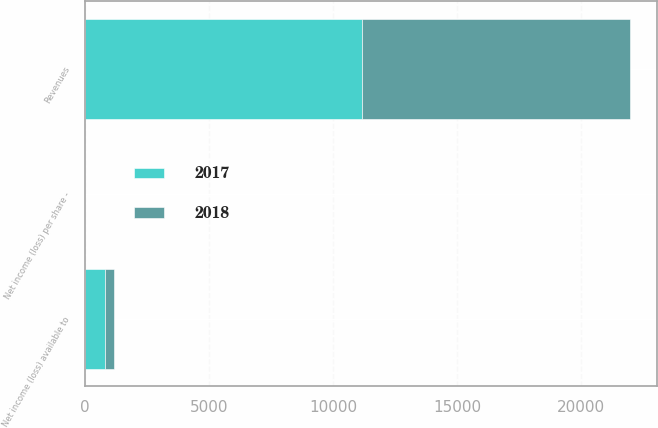Convert chart. <chart><loc_0><loc_0><loc_500><loc_500><stacked_bar_chart><ecel><fcel>Revenues<fcel>Net income (loss) available to<fcel>Net income (loss) per share -<nl><fcel>2017<fcel>11176<fcel>823<fcel>1.15<nl><fcel>2018<fcel>10790<fcel>329<fcel>0.47<nl></chart> 